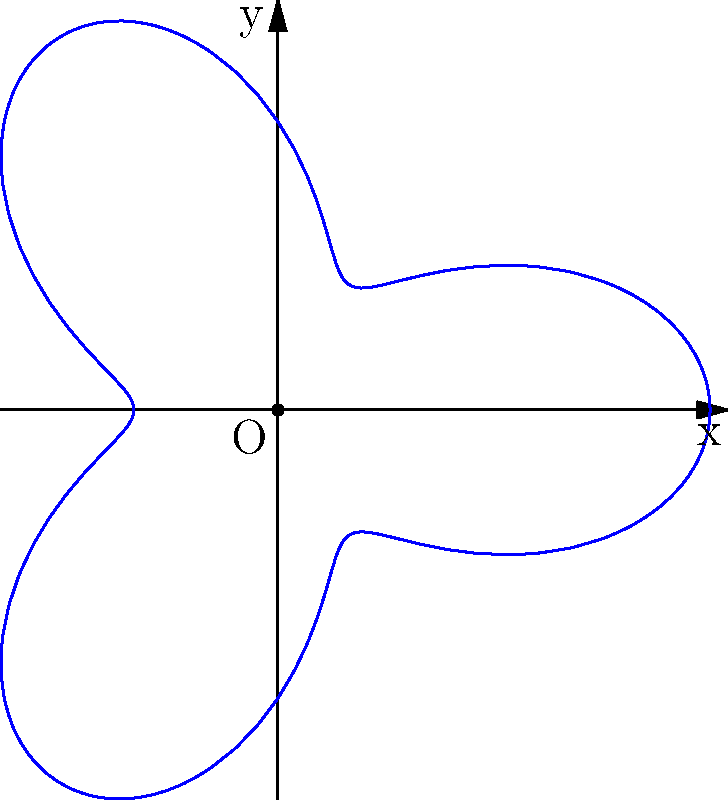Calculate the area of the irregular shape defined by the polar equation $r = 2 + \cos(3\theta)$ for $0 \leq \theta \leq 2\pi$. Round your answer to two decimal places. To calculate the area of an irregular shape defined in polar coordinates, we can use the formula:

$$ A = \frac{1}{2} \int_{0}^{2\pi} r^2 d\theta $$

For our shape, $r = 2 + \cos(3\theta)$. Let's follow these steps:

1) Square the radius function:
   $r^2 = (2 + \cos(3\theta))^2 = 4 + 4\cos(3\theta) + \cos^2(3\theta)$

2) Substitute this into the integral:
   $$ A = \frac{1}{2} \int_{0}^{2\pi} (4 + 4\cos(3\theta) + \cos^2(3\theta)) d\theta $$

3) Integrate term by term:
   - $\int_{0}^{2\pi} 4 d\theta = 4\theta |_{0}^{2\pi} = 8\pi$
   - $\int_{0}^{2\pi} 4\cos(3\theta) d\theta = \frac{4}{3}\sin(3\theta) |_{0}^{2\pi} = 0$
   - $\int_{0}^{2\pi} \cos^2(3\theta) d\theta = \frac{1}{2}\int_{0}^{2\pi} (1 + \cos(6\theta)) d\theta = \pi$

4) Sum up the results:
   $$ A = \frac{1}{2} (8\pi + 0 + \pi) = \frac{9\pi}{2} $$

5) Calculate the numeric value and round to two decimal places:
   $\frac{9\pi}{2} \approx 14.14$
Answer: 14.14 